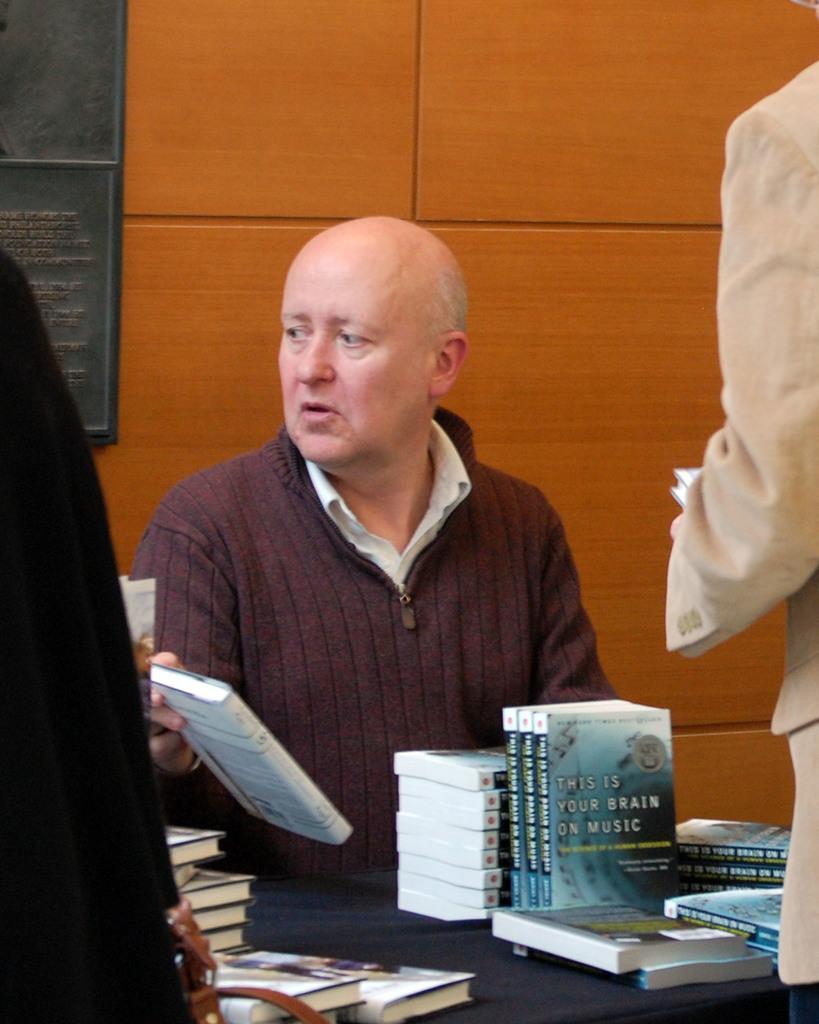Can you describe this image briefly? In this image I can see two people. One person is sitting and one person is standing. These people are wearing the different color dresses. There is a table in-front these people. On the table I can see the books. In the back there is a black color board to the brown color wall. 